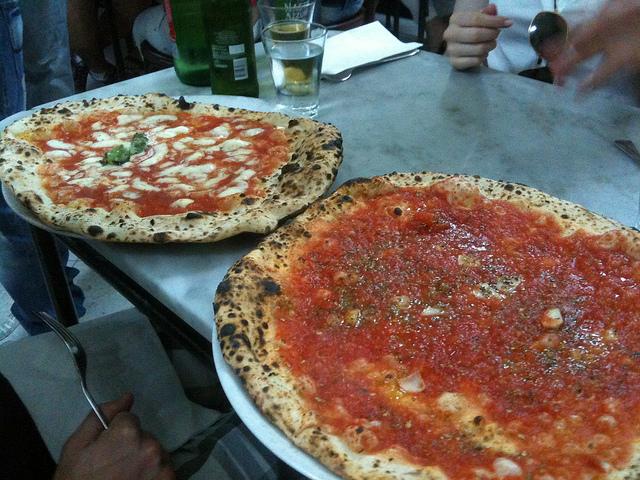Is the pizza still in the oven?
Concise answer only. No. How many pizzas are shown?
Concise answer only. 2. What type of sauce is on the pizza?
Be succinct. Tomato. 